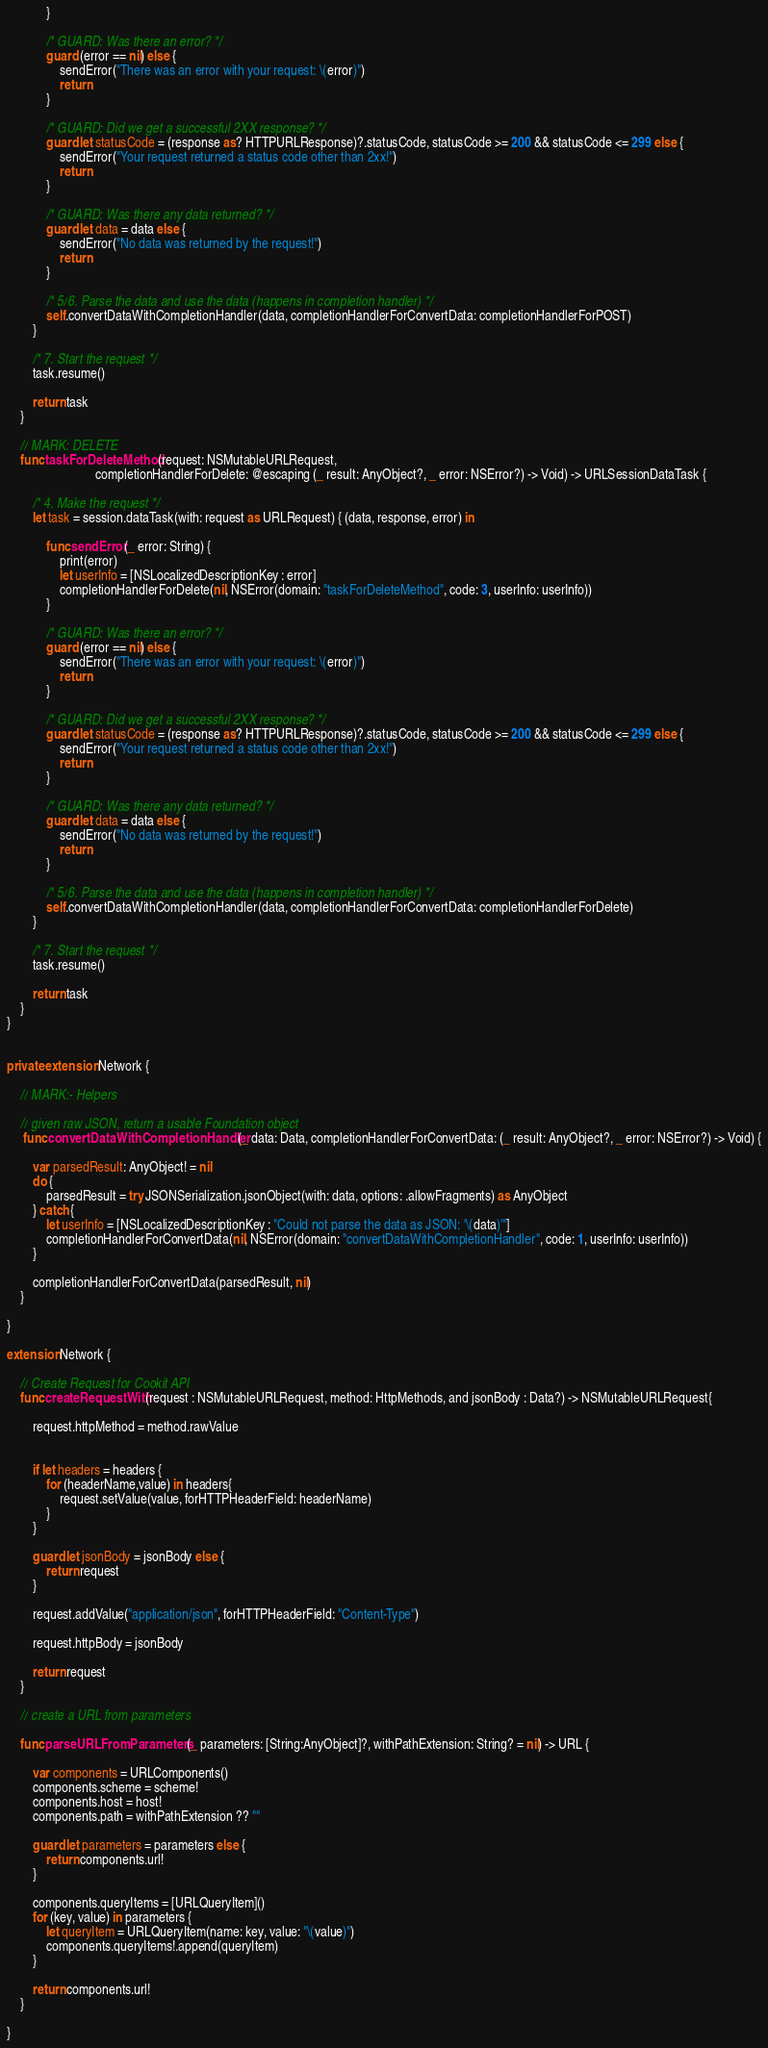<code> <loc_0><loc_0><loc_500><loc_500><_Swift_>            }
            
            /* GUARD: Was there an error? */
            guard (error == nil) else {
                sendError("There was an error with your request: \(error)")
                return
            }
            
            /* GUARD: Did we get a successful 2XX response? */
            guard let statusCode = (response as? HTTPURLResponse)?.statusCode, statusCode >= 200 && statusCode <= 299 else {
                sendError("Your request returned a status code other than 2xx!")
                return
            }
            
            /* GUARD: Was there any data returned? */
            guard let data = data else {
                sendError("No data was returned by the request!")
                return
            }
            
            /* 5/6. Parse the data and use the data (happens in completion handler) */
            self.convertDataWithCompletionHandler(data, completionHandlerForConvertData: completionHandlerForPOST)
        }
        
        /* 7. Start the request */
        task.resume()
        
        return task
    }
    
    // MARK: DELETE
    func taskForDeleteMethod(request: NSMutableURLRequest,
                           completionHandlerForDelete: @escaping (_ result: AnyObject?, _ error: NSError?) -> Void) -> URLSessionDataTask {
        
        /* 4. Make the request */
        let task = session.dataTask(with: request as URLRequest) { (data, response, error) in
            
            func sendError(_ error: String) {
                print(error)
                let userInfo = [NSLocalizedDescriptionKey : error]
                completionHandlerForDelete(nil, NSError(domain: "taskForDeleteMethod", code: 3, userInfo: userInfo))
            }
            
            /* GUARD: Was there an error? */
            guard (error == nil) else {
                sendError("There was an error with your request: \(error)")
                return
            }
            
            /* GUARD: Did we get a successful 2XX response? */
            guard let statusCode = (response as? HTTPURLResponse)?.statusCode, statusCode >= 200 && statusCode <= 299 else {
                sendError("Your request returned a status code other than 2xx!")
                return
            }
            
            /* GUARD: Was there any data returned? */
            guard let data = data else {
                sendError("No data was returned by the request!")
                return
            }
            
            /* 5/6. Parse the data and use the data (happens in completion handler) */
            self.convertDataWithCompletionHandler(data, completionHandlerForConvertData: completionHandlerForDelete)
        }
        
        /* 7. Start the request */
        task.resume()
        
        return task
    }
}


private extension Network {
    
    // MARK:- Helpers 
    
    // given raw JSON, return a usable Foundation object
     func convertDataWithCompletionHandler(_ data: Data, completionHandlerForConvertData: (_ result: AnyObject?, _ error: NSError?) -> Void) {
        
        var parsedResult: AnyObject! = nil
        do {
            parsedResult = try JSONSerialization.jsonObject(with: data, options: .allowFragments) as AnyObject
        } catch {
            let userInfo = [NSLocalizedDescriptionKey : "Could not parse the data as JSON: '\(data)'"]
            completionHandlerForConvertData(nil, NSError(domain: "convertDataWithCompletionHandler", code: 1, userInfo: userInfo))
        }
        
        completionHandlerForConvertData(parsedResult, nil)
    }
    
}

extension Network {
    
    // Create Request for Cookit API
    func createRequestWith(request : NSMutableURLRequest, method: HttpMethods, and jsonBody : Data?) -> NSMutableURLRequest{
        
        request.httpMethod = method.rawValue
        
        
        if let headers = headers {
            for (headerName,value) in headers{
                request.setValue(value, forHTTPHeaderField: headerName)
            }
        }

        guard let jsonBody = jsonBody else {
            return request
        }
        
        request.addValue("application/json", forHTTPHeaderField: "Content-Type")
        
        request.httpBody = jsonBody
        
        return request
    }
    
    // create a URL from parameters
    
    func parseURLFromParameters(_ parameters: [String:AnyObject]?, withPathExtension: String? = nil) -> URL {
        
        var components = URLComponents()
        components.scheme = scheme!
        components.host = host!
        components.path = withPathExtension ?? ""
        
        guard let parameters = parameters else {
            return components.url!
        }
        
        components.queryItems = [URLQueryItem]()
        for (key, value) in parameters {
            let queryItem = URLQueryItem(name: key, value: "\(value)")
            components.queryItems!.append(queryItem)
        }
        
        return components.url!
    }
    
}
</code> 